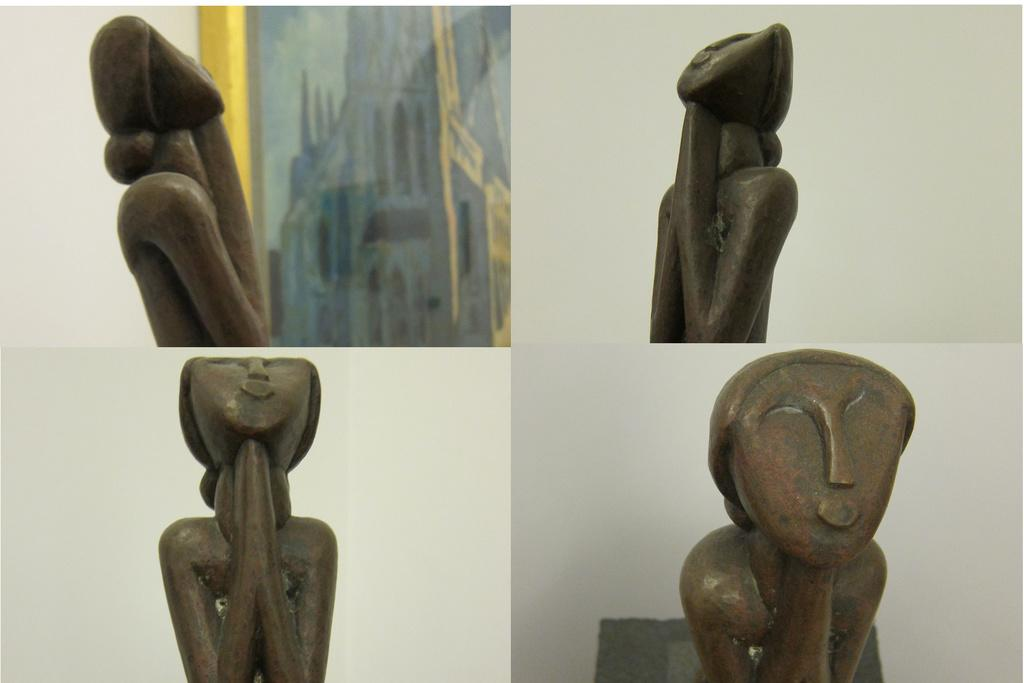What type of artwork is the image? The image is a collage. What type of objects can be seen in the collage? There are sculptures in thes in the collage. What is visible in the background of the collage? There is a wall in the background of the collage. Can you describe any specific features on the wall? There is a photo frame on the wall on the left side. How many girls are playing the horn in the image? There are no girls or horns present in the image. 